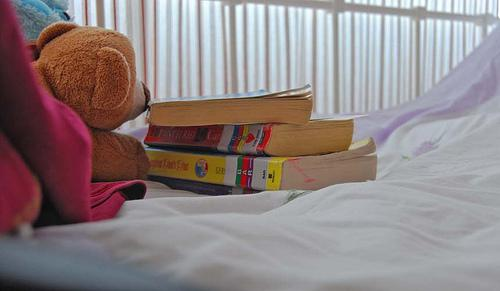Question: who is holding teddy bear?
Choices:
A. 1 person.
B. 2 people.
C. No one.
D. 3 people.
Answer with the letter. Answer: C Question: what main color is the bottom book?
Choices:
A. Red.
B. Green.
C. White.
D. Yellow.
Answer with the letter. Answer: D Question: where is the teddy bear?
Choices:
A. In the chair.
B. On the shelf.
C. On the floor.
D. On the bed.
Answer with the letter. Answer: D 